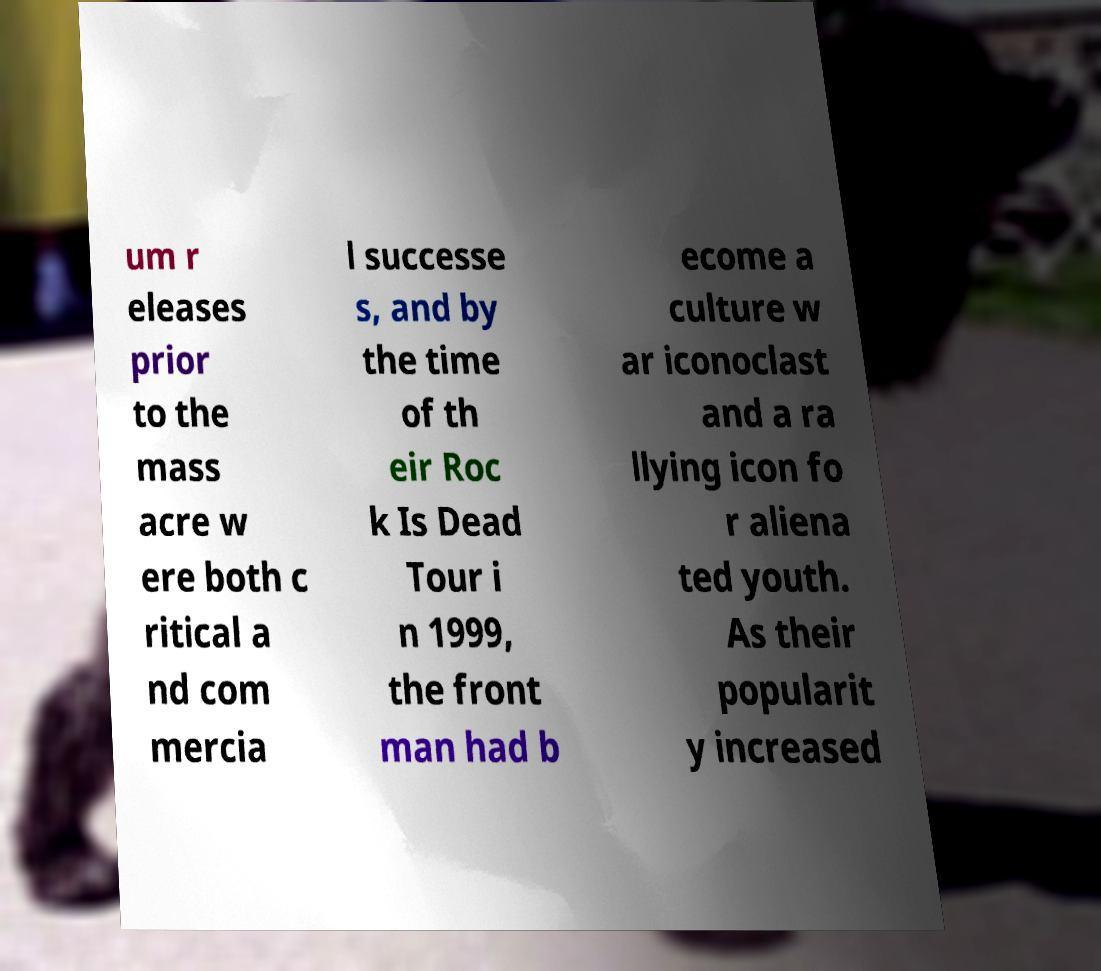What messages or text are displayed in this image? I need them in a readable, typed format. um r eleases prior to the mass acre w ere both c ritical a nd com mercia l successe s, and by the time of th eir Roc k Is Dead Tour i n 1999, the front man had b ecome a culture w ar iconoclast and a ra llying icon fo r aliena ted youth. As their popularit y increased 